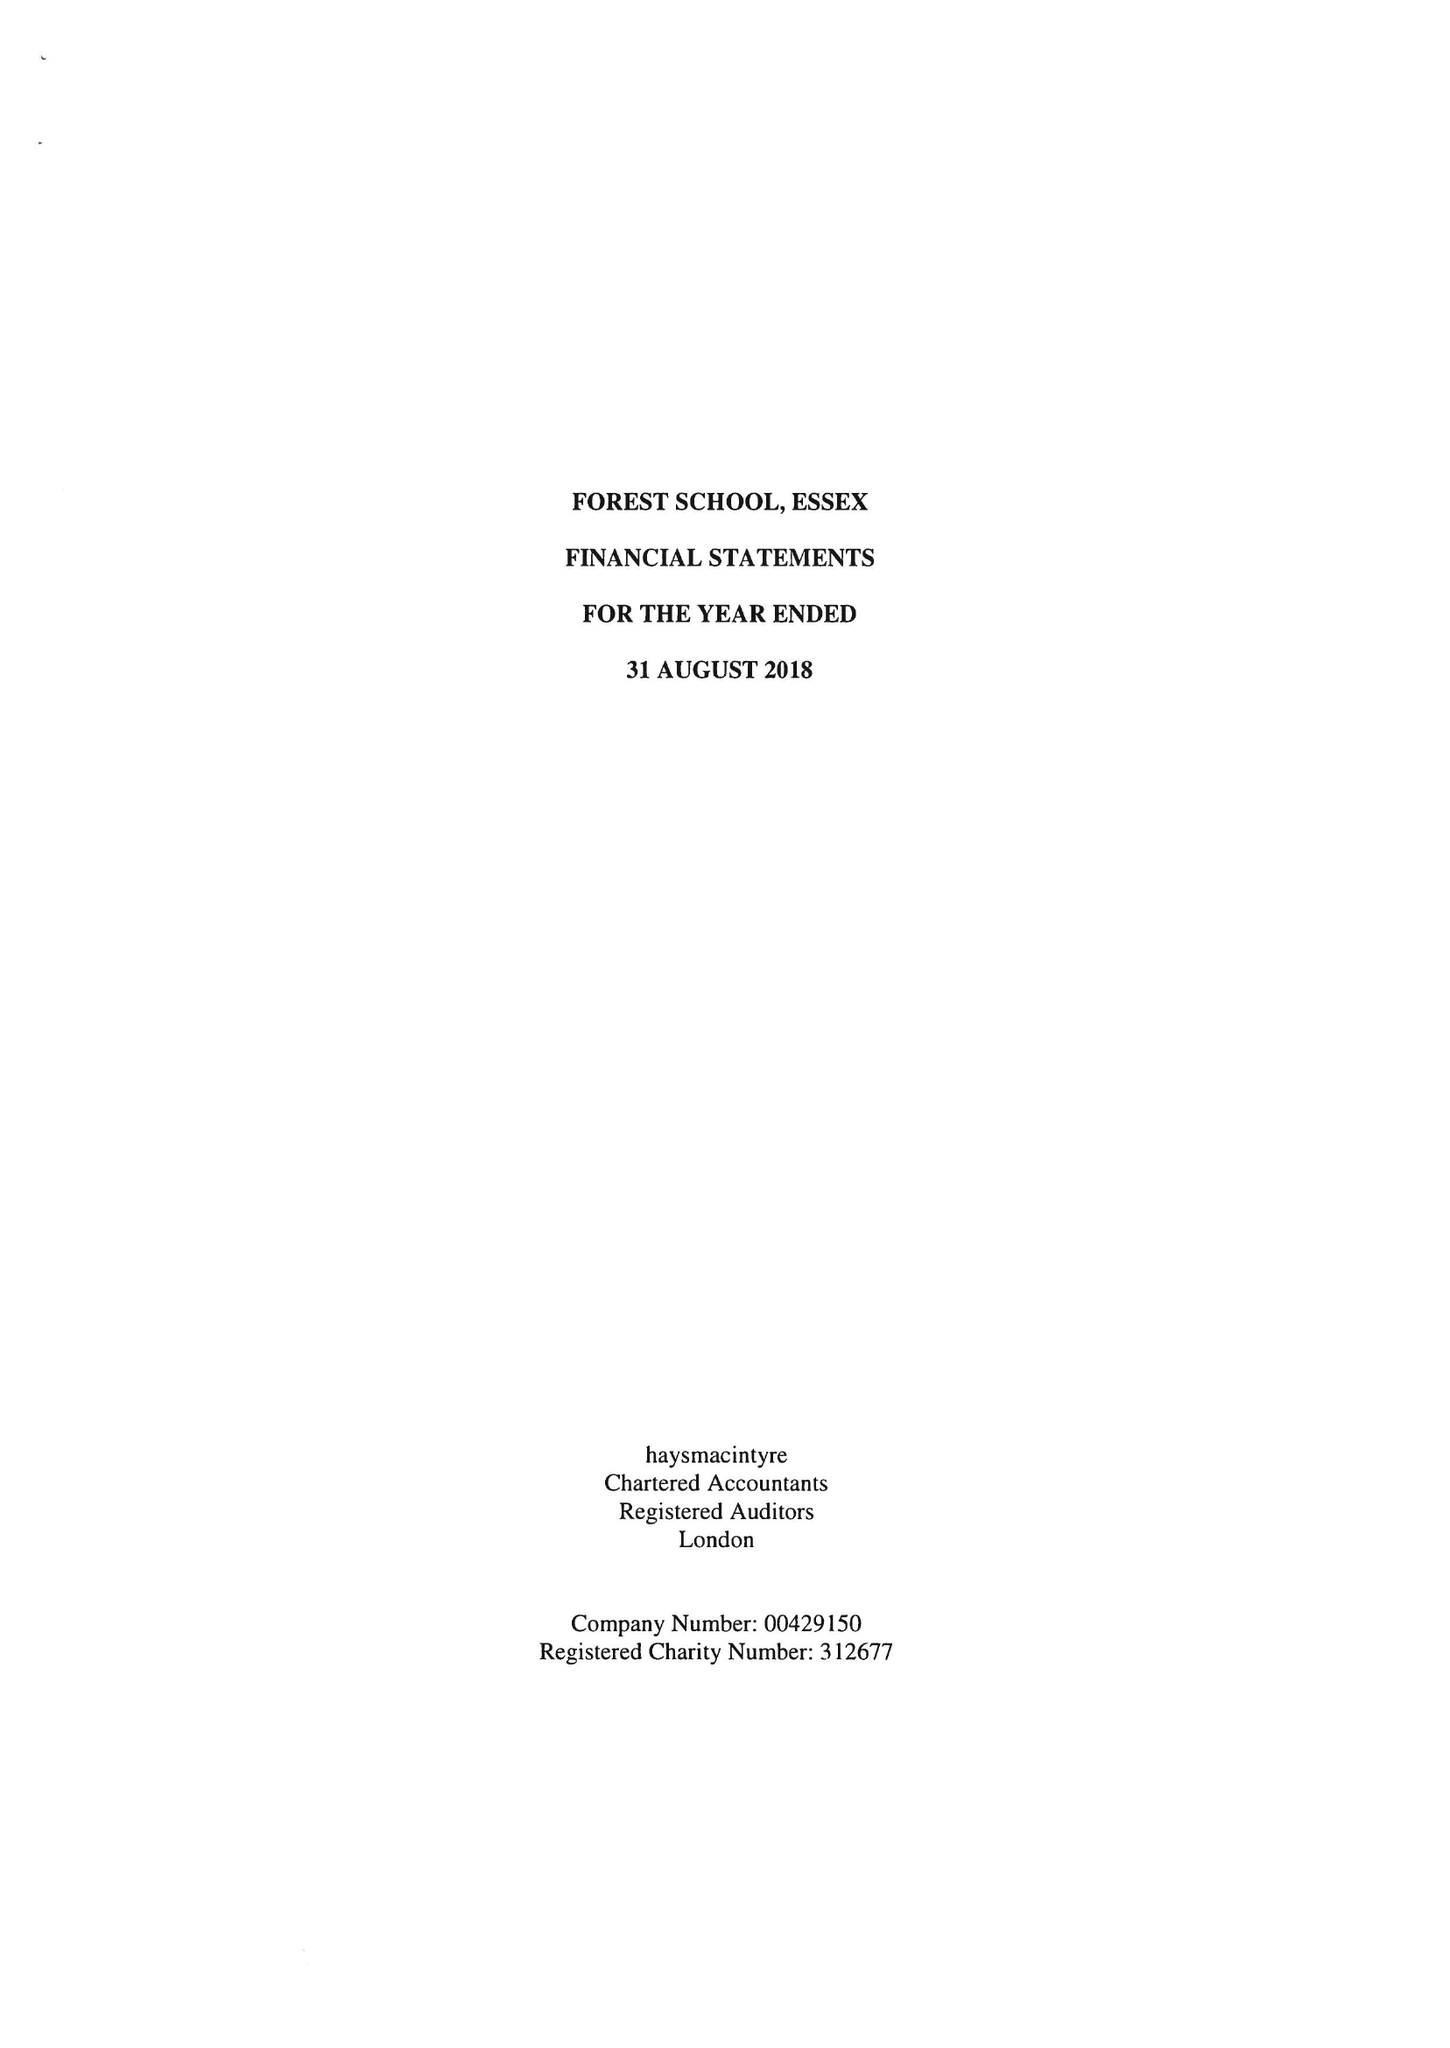What is the value for the income_annually_in_british_pounds?
Answer the question using a single word or phrase. 23041941.00 